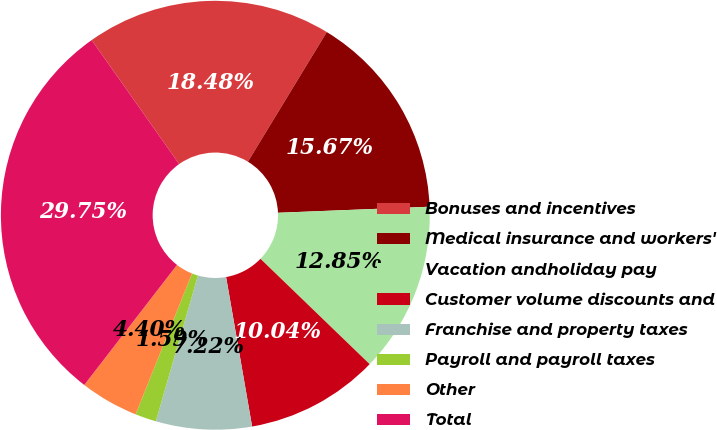<chart> <loc_0><loc_0><loc_500><loc_500><pie_chart><fcel>Bonuses and incentives<fcel>Medical insurance and workers'<fcel>Vacation andholiday pay<fcel>Customer volume discounts and<fcel>Franchise and property taxes<fcel>Payroll and payroll taxes<fcel>Other<fcel>Total<nl><fcel>18.48%<fcel>15.67%<fcel>12.85%<fcel>10.04%<fcel>7.22%<fcel>1.59%<fcel>4.4%<fcel>29.75%<nl></chart> 